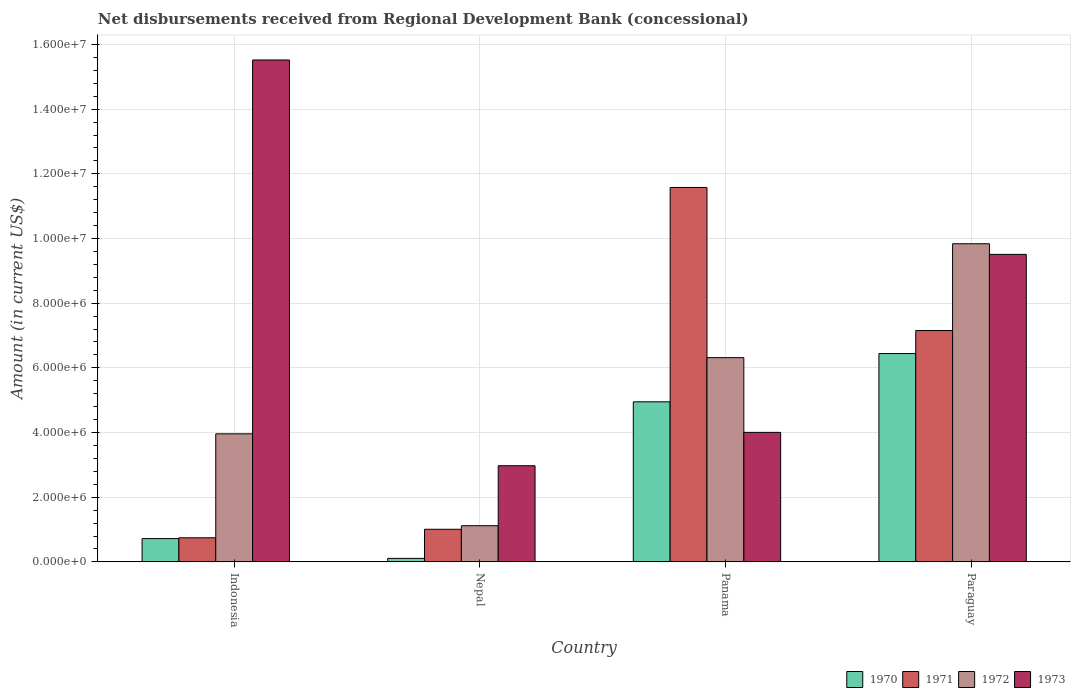How many groups of bars are there?
Ensure brevity in your answer.  4. Are the number of bars on each tick of the X-axis equal?
Make the answer very short. Yes. How many bars are there on the 4th tick from the left?
Your answer should be very brief. 4. What is the label of the 1st group of bars from the left?
Ensure brevity in your answer.  Indonesia. In how many cases, is the number of bars for a given country not equal to the number of legend labels?
Make the answer very short. 0. What is the amount of disbursements received from Regional Development Bank in 1972 in Nepal?
Give a very brief answer. 1.12e+06. Across all countries, what is the maximum amount of disbursements received from Regional Development Bank in 1970?
Provide a short and direct response. 6.44e+06. Across all countries, what is the minimum amount of disbursements received from Regional Development Bank in 1973?
Offer a terse response. 2.97e+06. In which country was the amount of disbursements received from Regional Development Bank in 1972 maximum?
Your response must be concise. Paraguay. In which country was the amount of disbursements received from Regional Development Bank in 1973 minimum?
Make the answer very short. Nepal. What is the total amount of disbursements received from Regional Development Bank in 1970 in the graph?
Offer a terse response. 1.22e+07. What is the difference between the amount of disbursements received from Regional Development Bank in 1970 in Nepal and that in Panama?
Your answer should be very brief. -4.84e+06. What is the difference between the amount of disbursements received from Regional Development Bank in 1971 in Paraguay and the amount of disbursements received from Regional Development Bank in 1972 in Panama?
Ensure brevity in your answer.  8.39e+05. What is the average amount of disbursements received from Regional Development Bank in 1971 per country?
Provide a succinct answer. 5.12e+06. What is the difference between the amount of disbursements received from Regional Development Bank of/in 1972 and amount of disbursements received from Regional Development Bank of/in 1971 in Paraguay?
Provide a succinct answer. 2.68e+06. What is the ratio of the amount of disbursements received from Regional Development Bank in 1971 in Nepal to that in Paraguay?
Your response must be concise. 0.14. Is the amount of disbursements received from Regional Development Bank in 1971 in Nepal less than that in Panama?
Give a very brief answer. Yes. What is the difference between the highest and the second highest amount of disbursements received from Regional Development Bank in 1972?
Provide a succinct answer. 3.52e+06. What is the difference between the highest and the lowest amount of disbursements received from Regional Development Bank in 1970?
Offer a very short reply. 6.33e+06. What does the 2nd bar from the left in Panama represents?
Ensure brevity in your answer.  1971. How many bars are there?
Your response must be concise. 16. Are all the bars in the graph horizontal?
Provide a short and direct response. No. What is the difference between two consecutive major ticks on the Y-axis?
Offer a terse response. 2.00e+06. Does the graph contain grids?
Keep it short and to the point. Yes. How many legend labels are there?
Offer a terse response. 4. What is the title of the graph?
Ensure brevity in your answer.  Net disbursements received from Regional Development Bank (concessional). Does "1965" appear as one of the legend labels in the graph?
Your response must be concise. No. What is the label or title of the X-axis?
Provide a succinct answer. Country. What is the label or title of the Y-axis?
Offer a very short reply. Amount (in current US$). What is the Amount (in current US$) in 1970 in Indonesia?
Provide a short and direct response. 7.20e+05. What is the Amount (in current US$) in 1971 in Indonesia?
Make the answer very short. 7.45e+05. What is the Amount (in current US$) in 1972 in Indonesia?
Ensure brevity in your answer.  3.96e+06. What is the Amount (in current US$) in 1973 in Indonesia?
Your answer should be very brief. 1.55e+07. What is the Amount (in current US$) of 1970 in Nepal?
Keep it short and to the point. 1.09e+05. What is the Amount (in current US$) in 1971 in Nepal?
Your response must be concise. 1.01e+06. What is the Amount (in current US$) of 1972 in Nepal?
Offer a very short reply. 1.12e+06. What is the Amount (in current US$) in 1973 in Nepal?
Provide a succinct answer. 2.97e+06. What is the Amount (in current US$) in 1970 in Panama?
Provide a succinct answer. 4.95e+06. What is the Amount (in current US$) in 1971 in Panama?
Provide a succinct answer. 1.16e+07. What is the Amount (in current US$) of 1972 in Panama?
Provide a succinct answer. 6.32e+06. What is the Amount (in current US$) in 1973 in Panama?
Make the answer very short. 4.00e+06. What is the Amount (in current US$) in 1970 in Paraguay?
Give a very brief answer. 6.44e+06. What is the Amount (in current US$) of 1971 in Paraguay?
Give a very brief answer. 7.16e+06. What is the Amount (in current US$) in 1972 in Paraguay?
Provide a short and direct response. 9.84e+06. What is the Amount (in current US$) of 1973 in Paraguay?
Your answer should be compact. 9.51e+06. Across all countries, what is the maximum Amount (in current US$) in 1970?
Make the answer very short. 6.44e+06. Across all countries, what is the maximum Amount (in current US$) of 1971?
Your answer should be very brief. 1.16e+07. Across all countries, what is the maximum Amount (in current US$) of 1972?
Give a very brief answer. 9.84e+06. Across all countries, what is the maximum Amount (in current US$) in 1973?
Provide a short and direct response. 1.55e+07. Across all countries, what is the minimum Amount (in current US$) of 1970?
Provide a short and direct response. 1.09e+05. Across all countries, what is the minimum Amount (in current US$) of 1971?
Provide a short and direct response. 7.45e+05. Across all countries, what is the minimum Amount (in current US$) of 1972?
Ensure brevity in your answer.  1.12e+06. Across all countries, what is the minimum Amount (in current US$) in 1973?
Offer a terse response. 2.97e+06. What is the total Amount (in current US$) of 1970 in the graph?
Your answer should be compact. 1.22e+07. What is the total Amount (in current US$) in 1971 in the graph?
Offer a terse response. 2.05e+07. What is the total Amount (in current US$) in 1972 in the graph?
Give a very brief answer. 2.12e+07. What is the total Amount (in current US$) of 1973 in the graph?
Ensure brevity in your answer.  3.20e+07. What is the difference between the Amount (in current US$) in 1970 in Indonesia and that in Nepal?
Ensure brevity in your answer.  6.11e+05. What is the difference between the Amount (in current US$) in 1971 in Indonesia and that in Nepal?
Make the answer very short. -2.63e+05. What is the difference between the Amount (in current US$) of 1972 in Indonesia and that in Nepal?
Keep it short and to the point. 2.84e+06. What is the difference between the Amount (in current US$) in 1973 in Indonesia and that in Nepal?
Give a very brief answer. 1.25e+07. What is the difference between the Amount (in current US$) of 1970 in Indonesia and that in Panama?
Offer a very short reply. -4.23e+06. What is the difference between the Amount (in current US$) in 1971 in Indonesia and that in Panama?
Ensure brevity in your answer.  -1.08e+07. What is the difference between the Amount (in current US$) in 1972 in Indonesia and that in Panama?
Offer a terse response. -2.36e+06. What is the difference between the Amount (in current US$) of 1973 in Indonesia and that in Panama?
Offer a very short reply. 1.15e+07. What is the difference between the Amount (in current US$) in 1970 in Indonesia and that in Paraguay?
Ensure brevity in your answer.  -5.72e+06. What is the difference between the Amount (in current US$) of 1971 in Indonesia and that in Paraguay?
Your answer should be very brief. -6.41e+06. What is the difference between the Amount (in current US$) of 1972 in Indonesia and that in Paraguay?
Your answer should be very brief. -5.88e+06. What is the difference between the Amount (in current US$) in 1973 in Indonesia and that in Paraguay?
Provide a succinct answer. 6.01e+06. What is the difference between the Amount (in current US$) of 1970 in Nepal and that in Panama?
Provide a short and direct response. -4.84e+06. What is the difference between the Amount (in current US$) of 1971 in Nepal and that in Panama?
Your answer should be very brief. -1.06e+07. What is the difference between the Amount (in current US$) in 1972 in Nepal and that in Panama?
Offer a very short reply. -5.20e+06. What is the difference between the Amount (in current US$) in 1973 in Nepal and that in Panama?
Keep it short and to the point. -1.03e+06. What is the difference between the Amount (in current US$) in 1970 in Nepal and that in Paraguay?
Offer a very short reply. -6.33e+06. What is the difference between the Amount (in current US$) in 1971 in Nepal and that in Paraguay?
Make the answer very short. -6.15e+06. What is the difference between the Amount (in current US$) of 1972 in Nepal and that in Paraguay?
Your answer should be compact. -8.72e+06. What is the difference between the Amount (in current US$) in 1973 in Nepal and that in Paraguay?
Give a very brief answer. -6.54e+06. What is the difference between the Amount (in current US$) of 1970 in Panama and that in Paraguay?
Provide a short and direct response. -1.49e+06. What is the difference between the Amount (in current US$) in 1971 in Panama and that in Paraguay?
Ensure brevity in your answer.  4.42e+06. What is the difference between the Amount (in current US$) in 1972 in Panama and that in Paraguay?
Your response must be concise. -3.52e+06. What is the difference between the Amount (in current US$) of 1973 in Panama and that in Paraguay?
Offer a very short reply. -5.50e+06. What is the difference between the Amount (in current US$) in 1970 in Indonesia and the Amount (in current US$) in 1971 in Nepal?
Provide a short and direct response. -2.88e+05. What is the difference between the Amount (in current US$) in 1970 in Indonesia and the Amount (in current US$) in 1972 in Nepal?
Provide a succinct answer. -3.98e+05. What is the difference between the Amount (in current US$) in 1970 in Indonesia and the Amount (in current US$) in 1973 in Nepal?
Your response must be concise. -2.25e+06. What is the difference between the Amount (in current US$) of 1971 in Indonesia and the Amount (in current US$) of 1972 in Nepal?
Provide a short and direct response. -3.73e+05. What is the difference between the Amount (in current US$) of 1971 in Indonesia and the Amount (in current US$) of 1973 in Nepal?
Make the answer very short. -2.23e+06. What is the difference between the Amount (in current US$) in 1972 in Indonesia and the Amount (in current US$) in 1973 in Nepal?
Give a very brief answer. 9.87e+05. What is the difference between the Amount (in current US$) in 1970 in Indonesia and the Amount (in current US$) in 1971 in Panama?
Provide a short and direct response. -1.09e+07. What is the difference between the Amount (in current US$) in 1970 in Indonesia and the Amount (in current US$) in 1972 in Panama?
Keep it short and to the point. -5.60e+06. What is the difference between the Amount (in current US$) in 1970 in Indonesia and the Amount (in current US$) in 1973 in Panama?
Provide a short and direct response. -3.28e+06. What is the difference between the Amount (in current US$) of 1971 in Indonesia and the Amount (in current US$) of 1972 in Panama?
Offer a very short reply. -5.57e+06. What is the difference between the Amount (in current US$) in 1971 in Indonesia and the Amount (in current US$) in 1973 in Panama?
Offer a very short reply. -3.26e+06. What is the difference between the Amount (in current US$) in 1972 in Indonesia and the Amount (in current US$) in 1973 in Panama?
Offer a very short reply. -4.50e+04. What is the difference between the Amount (in current US$) in 1970 in Indonesia and the Amount (in current US$) in 1971 in Paraguay?
Provide a succinct answer. -6.44e+06. What is the difference between the Amount (in current US$) of 1970 in Indonesia and the Amount (in current US$) of 1972 in Paraguay?
Keep it short and to the point. -9.12e+06. What is the difference between the Amount (in current US$) in 1970 in Indonesia and the Amount (in current US$) in 1973 in Paraguay?
Offer a very short reply. -8.79e+06. What is the difference between the Amount (in current US$) of 1971 in Indonesia and the Amount (in current US$) of 1972 in Paraguay?
Your answer should be compact. -9.09e+06. What is the difference between the Amount (in current US$) in 1971 in Indonesia and the Amount (in current US$) in 1973 in Paraguay?
Ensure brevity in your answer.  -8.76e+06. What is the difference between the Amount (in current US$) of 1972 in Indonesia and the Amount (in current US$) of 1973 in Paraguay?
Offer a very short reply. -5.55e+06. What is the difference between the Amount (in current US$) of 1970 in Nepal and the Amount (in current US$) of 1971 in Panama?
Offer a very short reply. -1.15e+07. What is the difference between the Amount (in current US$) of 1970 in Nepal and the Amount (in current US$) of 1972 in Panama?
Your response must be concise. -6.21e+06. What is the difference between the Amount (in current US$) of 1970 in Nepal and the Amount (in current US$) of 1973 in Panama?
Your answer should be very brief. -3.90e+06. What is the difference between the Amount (in current US$) of 1971 in Nepal and the Amount (in current US$) of 1972 in Panama?
Ensure brevity in your answer.  -5.31e+06. What is the difference between the Amount (in current US$) in 1971 in Nepal and the Amount (in current US$) in 1973 in Panama?
Offer a very short reply. -3.00e+06. What is the difference between the Amount (in current US$) in 1972 in Nepal and the Amount (in current US$) in 1973 in Panama?
Give a very brief answer. -2.89e+06. What is the difference between the Amount (in current US$) of 1970 in Nepal and the Amount (in current US$) of 1971 in Paraguay?
Provide a succinct answer. -7.05e+06. What is the difference between the Amount (in current US$) in 1970 in Nepal and the Amount (in current US$) in 1972 in Paraguay?
Your answer should be very brief. -9.73e+06. What is the difference between the Amount (in current US$) in 1970 in Nepal and the Amount (in current US$) in 1973 in Paraguay?
Offer a very short reply. -9.40e+06. What is the difference between the Amount (in current US$) in 1971 in Nepal and the Amount (in current US$) in 1972 in Paraguay?
Give a very brief answer. -8.83e+06. What is the difference between the Amount (in current US$) in 1971 in Nepal and the Amount (in current US$) in 1973 in Paraguay?
Your response must be concise. -8.50e+06. What is the difference between the Amount (in current US$) of 1972 in Nepal and the Amount (in current US$) of 1973 in Paraguay?
Your answer should be compact. -8.39e+06. What is the difference between the Amount (in current US$) of 1970 in Panama and the Amount (in current US$) of 1971 in Paraguay?
Give a very brief answer. -2.20e+06. What is the difference between the Amount (in current US$) of 1970 in Panama and the Amount (in current US$) of 1972 in Paraguay?
Provide a succinct answer. -4.89e+06. What is the difference between the Amount (in current US$) in 1970 in Panama and the Amount (in current US$) in 1973 in Paraguay?
Ensure brevity in your answer.  -4.56e+06. What is the difference between the Amount (in current US$) in 1971 in Panama and the Amount (in current US$) in 1972 in Paraguay?
Offer a terse response. 1.74e+06. What is the difference between the Amount (in current US$) in 1971 in Panama and the Amount (in current US$) in 1973 in Paraguay?
Provide a short and direct response. 2.07e+06. What is the difference between the Amount (in current US$) of 1972 in Panama and the Amount (in current US$) of 1973 in Paraguay?
Offer a terse response. -3.19e+06. What is the average Amount (in current US$) of 1970 per country?
Provide a succinct answer. 3.06e+06. What is the average Amount (in current US$) in 1971 per country?
Provide a short and direct response. 5.12e+06. What is the average Amount (in current US$) in 1972 per country?
Provide a short and direct response. 5.31e+06. What is the average Amount (in current US$) of 1973 per country?
Make the answer very short. 8.00e+06. What is the difference between the Amount (in current US$) of 1970 and Amount (in current US$) of 1971 in Indonesia?
Your answer should be compact. -2.50e+04. What is the difference between the Amount (in current US$) of 1970 and Amount (in current US$) of 1972 in Indonesia?
Give a very brief answer. -3.24e+06. What is the difference between the Amount (in current US$) of 1970 and Amount (in current US$) of 1973 in Indonesia?
Make the answer very short. -1.48e+07. What is the difference between the Amount (in current US$) in 1971 and Amount (in current US$) in 1972 in Indonesia?
Make the answer very short. -3.22e+06. What is the difference between the Amount (in current US$) of 1971 and Amount (in current US$) of 1973 in Indonesia?
Make the answer very short. -1.48e+07. What is the difference between the Amount (in current US$) of 1972 and Amount (in current US$) of 1973 in Indonesia?
Provide a succinct answer. -1.16e+07. What is the difference between the Amount (in current US$) in 1970 and Amount (in current US$) in 1971 in Nepal?
Provide a succinct answer. -8.99e+05. What is the difference between the Amount (in current US$) in 1970 and Amount (in current US$) in 1972 in Nepal?
Ensure brevity in your answer.  -1.01e+06. What is the difference between the Amount (in current US$) of 1970 and Amount (in current US$) of 1973 in Nepal?
Your answer should be very brief. -2.86e+06. What is the difference between the Amount (in current US$) in 1971 and Amount (in current US$) in 1972 in Nepal?
Your answer should be compact. -1.10e+05. What is the difference between the Amount (in current US$) in 1971 and Amount (in current US$) in 1973 in Nepal?
Offer a very short reply. -1.96e+06. What is the difference between the Amount (in current US$) of 1972 and Amount (in current US$) of 1973 in Nepal?
Your answer should be very brief. -1.86e+06. What is the difference between the Amount (in current US$) in 1970 and Amount (in current US$) in 1971 in Panama?
Provide a succinct answer. -6.63e+06. What is the difference between the Amount (in current US$) in 1970 and Amount (in current US$) in 1972 in Panama?
Your response must be concise. -1.37e+06. What is the difference between the Amount (in current US$) of 1970 and Amount (in current US$) of 1973 in Panama?
Provide a succinct answer. 9.45e+05. What is the difference between the Amount (in current US$) in 1971 and Amount (in current US$) in 1972 in Panama?
Your response must be concise. 5.26e+06. What is the difference between the Amount (in current US$) of 1971 and Amount (in current US$) of 1973 in Panama?
Keep it short and to the point. 7.57e+06. What is the difference between the Amount (in current US$) in 1972 and Amount (in current US$) in 1973 in Panama?
Provide a succinct answer. 2.31e+06. What is the difference between the Amount (in current US$) of 1970 and Amount (in current US$) of 1971 in Paraguay?
Your answer should be compact. -7.12e+05. What is the difference between the Amount (in current US$) in 1970 and Amount (in current US$) in 1972 in Paraguay?
Keep it short and to the point. -3.40e+06. What is the difference between the Amount (in current US$) in 1970 and Amount (in current US$) in 1973 in Paraguay?
Keep it short and to the point. -3.07e+06. What is the difference between the Amount (in current US$) of 1971 and Amount (in current US$) of 1972 in Paraguay?
Keep it short and to the point. -2.68e+06. What is the difference between the Amount (in current US$) of 1971 and Amount (in current US$) of 1973 in Paraguay?
Ensure brevity in your answer.  -2.36e+06. What is the difference between the Amount (in current US$) of 1972 and Amount (in current US$) of 1973 in Paraguay?
Give a very brief answer. 3.28e+05. What is the ratio of the Amount (in current US$) in 1970 in Indonesia to that in Nepal?
Ensure brevity in your answer.  6.61. What is the ratio of the Amount (in current US$) in 1971 in Indonesia to that in Nepal?
Keep it short and to the point. 0.74. What is the ratio of the Amount (in current US$) in 1972 in Indonesia to that in Nepal?
Provide a succinct answer. 3.54. What is the ratio of the Amount (in current US$) in 1973 in Indonesia to that in Nepal?
Provide a short and direct response. 5.22. What is the ratio of the Amount (in current US$) of 1970 in Indonesia to that in Panama?
Give a very brief answer. 0.15. What is the ratio of the Amount (in current US$) in 1971 in Indonesia to that in Panama?
Your response must be concise. 0.06. What is the ratio of the Amount (in current US$) in 1972 in Indonesia to that in Panama?
Keep it short and to the point. 0.63. What is the ratio of the Amount (in current US$) of 1973 in Indonesia to that in Panama?
Your answer should be compact. 3.88. What is the ratio of the Amount (in current US$) in 1970 in Indonesia to that in Paraguay?
Provide a succinct answer. 0.11. What is the ratio of the Amount (in current US$) in 1971 in Indonesia to that in Paraguay?
Offer a very short reply. 0.1. What is the ratio of the Amount (in current US$) in 1972 in Indonesia to that in Paraguay?
Give a very brief answer. 0.4. What is the ratio of the Amount (in current US$) in 1973 in Indonesia to that in Paraguay?
Provide a succinct answer. 1.63. What is the ratio of the Amount (in current US$) of 1970 in Nepal to that in Panama?
Offer a very short reply. 0.02. What is the ratio of the Amount (in current US$) in 1971 in Nepal to that in Panama?
Your answer should be compact. 0.09. What is the ratio of the Amount (in current US$) of 1972 in Nepal to that in Panama?
Your answer should be very brief. 0.18. What is the ratio of the Amount (in current US$) in 1973 in Nepal to that in Panama?
Your answer should be very brief. 0.74. What is the ratio of the Amount (in current US$) in 1970 in Nepal to that in Paraguay?
Offer a terse response. 0.02. What is the ratio of the Amount (in current US$) in 1971 in Nepal to that in Paraguay?
Your answer should be very brief. 0.14. What is the ratio of the Amount (in current US$) of 1972 in Nepal to that in Paraguay?
Your answer should be compact. 0.11. What is the ratio of the Amount (in current US$) in 1973 in Nepal to that in Paraguay?
Provide a succinct answer. 0.31. What is the ratio of the Amount (in current US$) in 1970 in Panama to that in Paraguay?
Your answer should be very brief. 0.77. What is the ratio of the Amount (in current US$) of 1971 in Panama to that in Paraguay?
Make the answer very short. 1.62. What is the ratio of the Amount (in current US$) of 1972 in Panama to that in Paraguay?
Ensure brevity in your answer.  0.64. What is the ratio of the Amount (in current US$) of 1973 in Panama to that in Paraguay?
Offer a very short reply. 0.42. What is the difference between the highest and the second highest Amount (in current US$) of 1970?
Keep it short and to the point. 1.49e+06. What is the difference between the highest and the second highest Amount (in current US$) of 1971?
Your answer should be compact. 4.42e+06. What is the difference between the highest and the second highest Amount (in current US$) in 1972?
Provide a succinct answer. 3.52e+06. What is the difference between the highest and the second highest Amount (in current US$) of 1973?
Provide a succinct answer. 6.01e+06. What is the difference between the highest and the lowest Amount (in current US$) of 1970?
Give a very brief answer. 6.33e+06. What is the difference between the highest and the lowest Amount (in current US$) in 1971?
Give a very brief answer. 1.08e+07. What is the difference between the highest and the lowest Amount (in current US$) in 1972?
Keep it short and to the point. 8.72e+06. What is the difference between the highest and the lowest Amount (in current US$) in 1973?
Offer a terse response. 1.25e+07. 